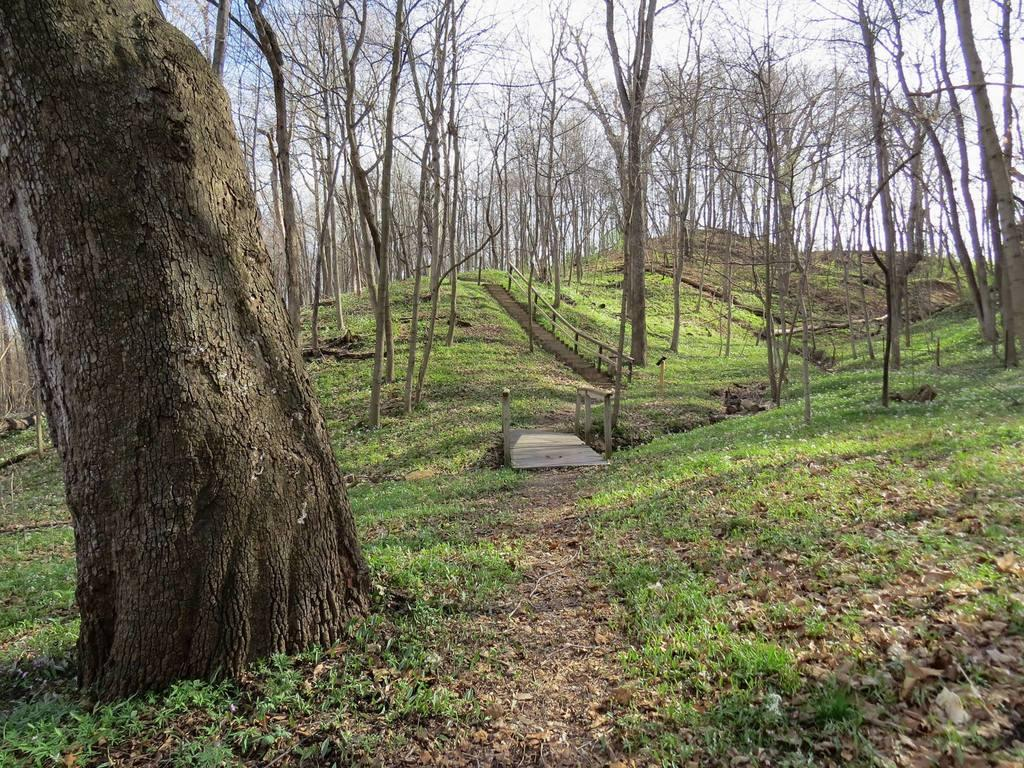What type of vegetation can be seen in the image? There is grass and trees in the image. What material are the objects made of in the image? The objects in the image are made of wood. What is visible in the background of the image? The sky is visible in the image. Can you describe the setting of the image? The image might have been taken in a forest, given the presence of grass, trees, and wooden objects. What type of love can be seen in the image? There is no love present in the image; it features grass, trees, and wooden objects. What is the texture of the knife in the image? There is no knife present in the image. 